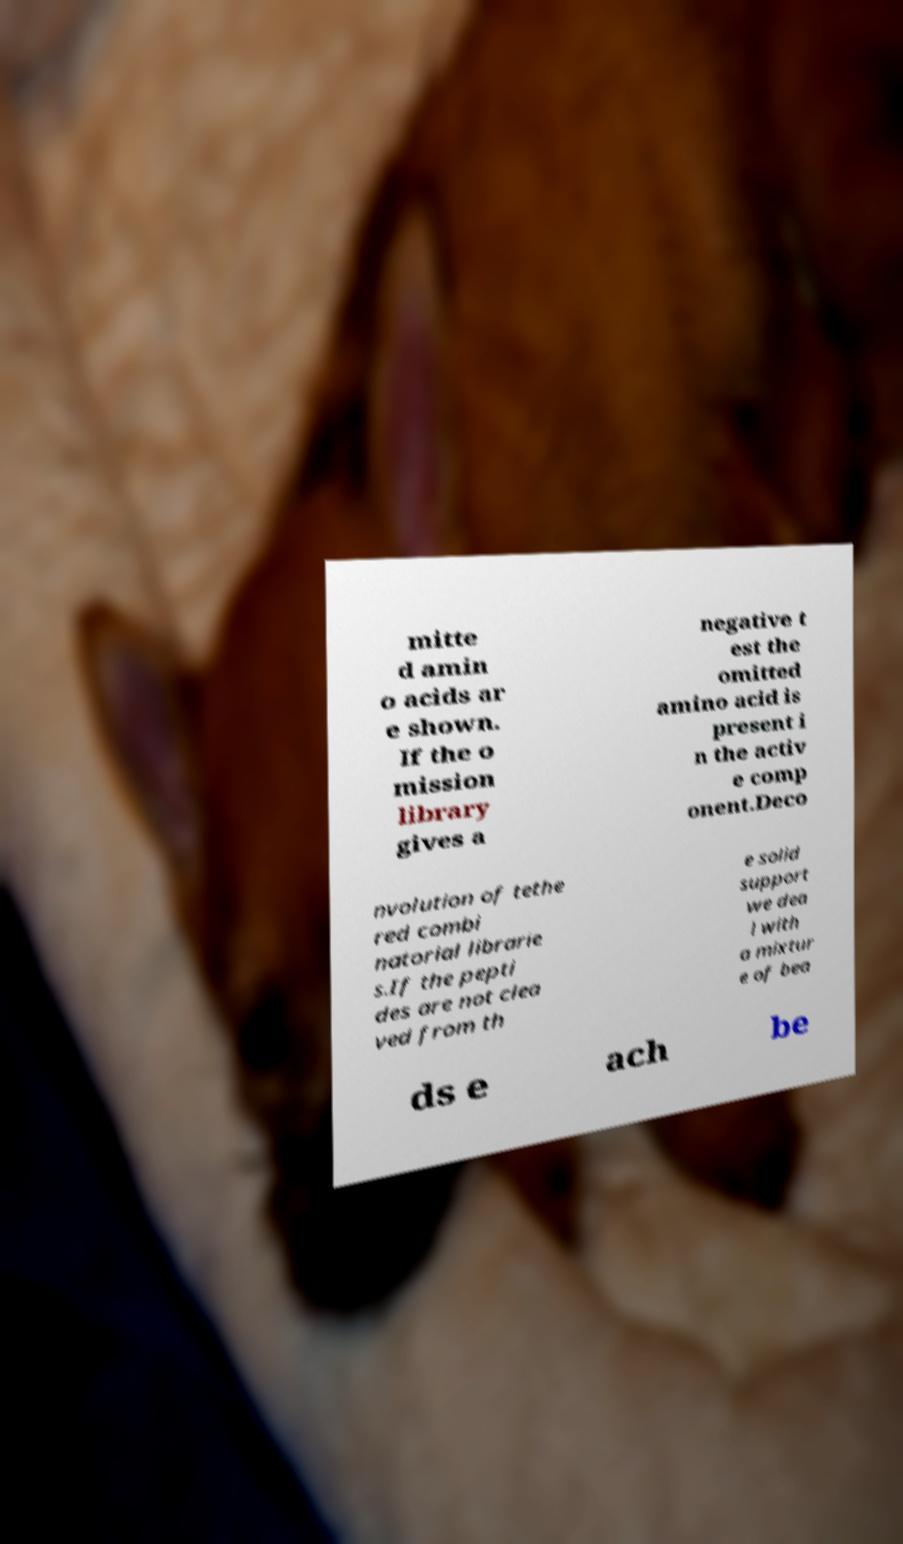Please read and relay the text visible in this image. What does it say? mitte d amin o acids ar e shown. If the o mission library gives a negative t est the omitted amino acid is present i n the activ e comp onent.Deco nvolution of tethe red combi natorial librarie s.If the pepti des are not clea ved from th e solid support we dea l with a mixtur e of bea ds e ach be 